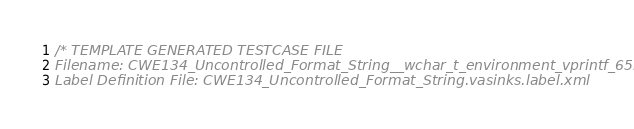<code> <loc_0><loc_0><loc_500><loc_500><_C_>/* TEMPLATE GENERATED TESTCASE FILE
Filename: CWE134_Uncontrolled_Format_String__wchar_t_environment_vprintf_65b.c
Label Definition File: CWE134_Uncontrolled_Format_String.vasinks.label.xml</code> 